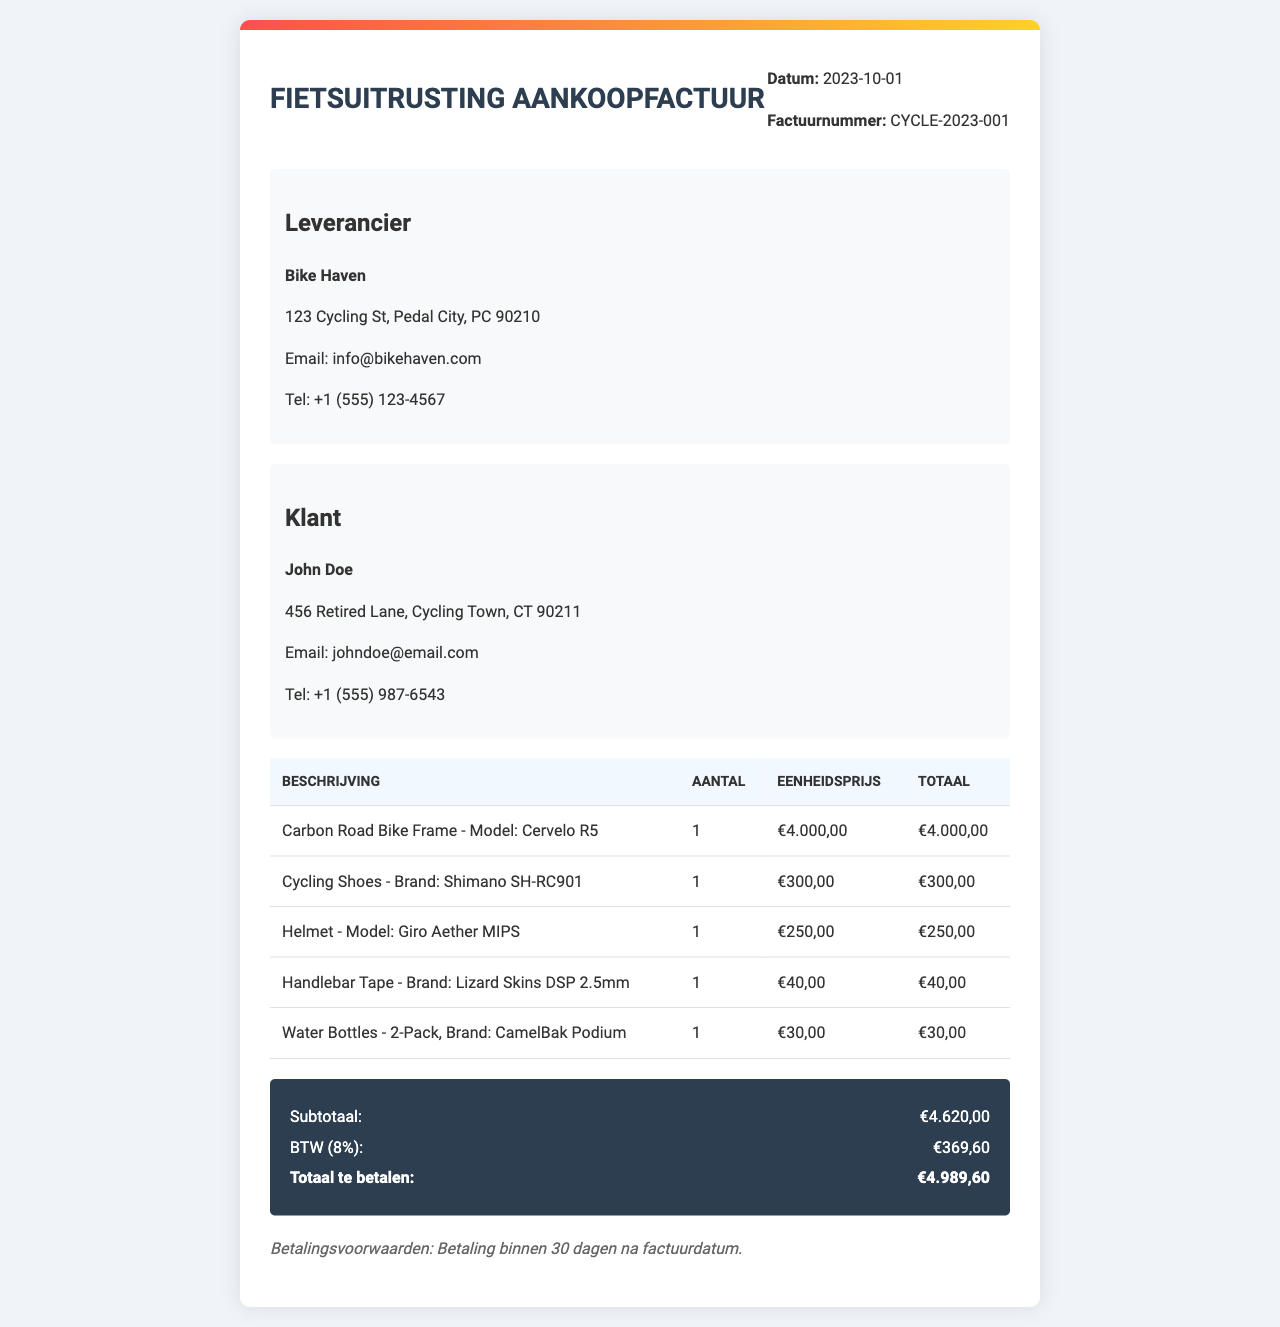wat is de factuurnummer? Het factuurnummer is duidelijk vermeld in de kop van de factuur onder het datumvak.
Answer: CYCLE-2023-001 wat is de datum van de factuur? De datum van de factuur staat ook vermeld in de kop van de factuur, naast het factuurnummer.
Answer: 2023-10-01 hoeveel kost de Carbon Road Bike Frame? De prijs van de Carbon Road Bike Frame staat in de tabel met de aankopen.
Answer: €4.000,00 wie is de leverancier? De naam van de leverancier is aangegeven in de sectie 'Leverancier' van de factuur.
Answer: Bike Haven hoeveel bedraagt de BTW? De BTW wordt weergegeven in de samenvatting aan het einde van de factuur en is een percentage van het subtotaal.
Answer: €369,60 wat is het totaal te betalen bedrag? Het totaal te betalen bedrag staat prominent in de samenvatting onder de andere kosten.
Answer: €4.989,60 hoeveel waterflessen zijn er gekocht? Het aantal waterflessen dat is gekocht, staat in de tabel die de artikelen beschrijft.
Answer: 1 wat is het aantal coureurs schoenen gekocht? Het aantal paar coureurs schoenen dat is gekocht, is ook vermeld in de tabel.
Answer: 1 wat zijn de betalingsvoorwaarden? De betalingsvoorwaarden worden weergegeven aan het einde van de factuur, onder de samenvatting.
Answer: Betaling binnen 30 dagen na factuurdatum 